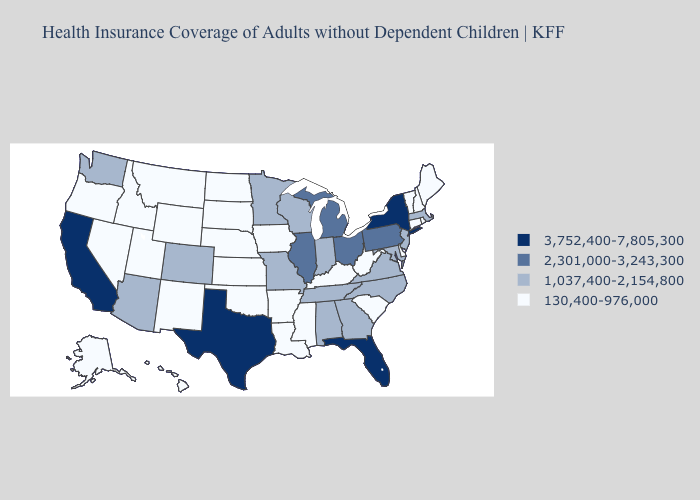Name the states that have a value in the range 2,301,000-3,243,300?
Be succinct. Illinois, Michigan, Ohio, Pennsylvania. Does California have the lowest value in the West?
Write a very short answer. No. Does Minnesota have the highest value in the USA?
Give a very brief answer. No. What is the value of Wyoming?
Write a very short answer. 130,400-976,000. What is the value of Oklahoma?
Concise answer only. 130,400-976,000. What is the lowest value in the USA?
Give a very brief answer. 130,400-976,000. Name the states that have a value in the range 130,400-976,000?
Give a very brief answer. Alaska, Arkansas, Connecticut, Delaware, Hawaii, Idaho, Iowa, Kansas, Kentucky, Louisiana, Maine, Mississippi, Montana, Nebraska, Nevada, New Hampshire, New Mexico, North Dakota, Oklahoma, Oregon, Rhode Island, South Carolina, South Dakota, Utah, Vermont, West Virginia, Wyoming. Name the states that have a value in the range 1,037,400-2,154,800?
Quick response, please. Alabama, Arizona, Colorado, Georgia, Indiana, Maryland, Massachusetts, Minnesota, Missouri, New Jersey, North Carolina, Tennessee, Virginia, Washington, Wisconsin. What is the value of Washington?
Answer briefly. 1,037,400-2,154,800. What is the value of West Virginia?
Answer briefly. 130,400-976,000. Does the map have missing data?
Give a very brief answer. No. Which states have the lowest value in the West?
Keep it brief. Alaska, Hawaii, Idaho, Montana, Nevada, New Mexico, Oregon, Utah, Wyoming. Name the states that have a value in the range 3,752,400-7,805,300?
Keep it brief. California, Florida, New York, Texas. Is the legend a continuous bar?
Short answer required. No. 